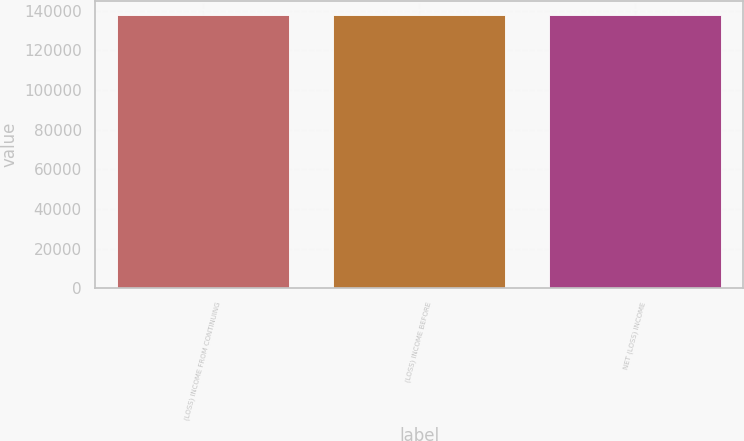<chart> <loc_0><loc_0><loc_500><loc_500><bar_chart><fcel>(LOSS) INCOME FROM CONTINUING<fcel>(LOSS) INCOME BEFORE<fcel>NET (LOSS) INCOME<nl><fcel>138041<fcel>138041<fcel>138041<nl></chart> 